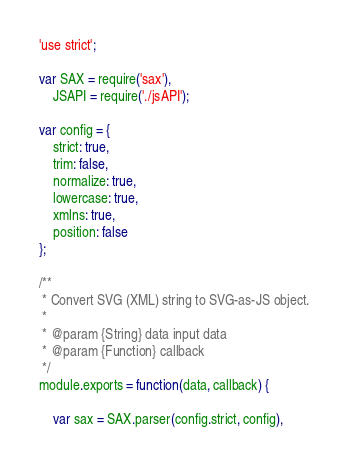Convert code to text. <code><loc_0><loc_0><loc_500><loc_500><_JavaScript_>'use strict';

var SAX = require('sax'),
    JSAPI = require('./jsAPI');

var config = {
    strict: true,
    trim: false,
    normalize: true,
    lowercase: true,
    xmlns: true,
    position: false
};

/**
 * Convert SVG (XML) string to SVG-as-JS object.
 *
 * @param {String} data input data
 * @param {Function} callback
 */
module.exports = function(data, callback) {

    var sax = SAX.parser(config.strict, config),</code> 